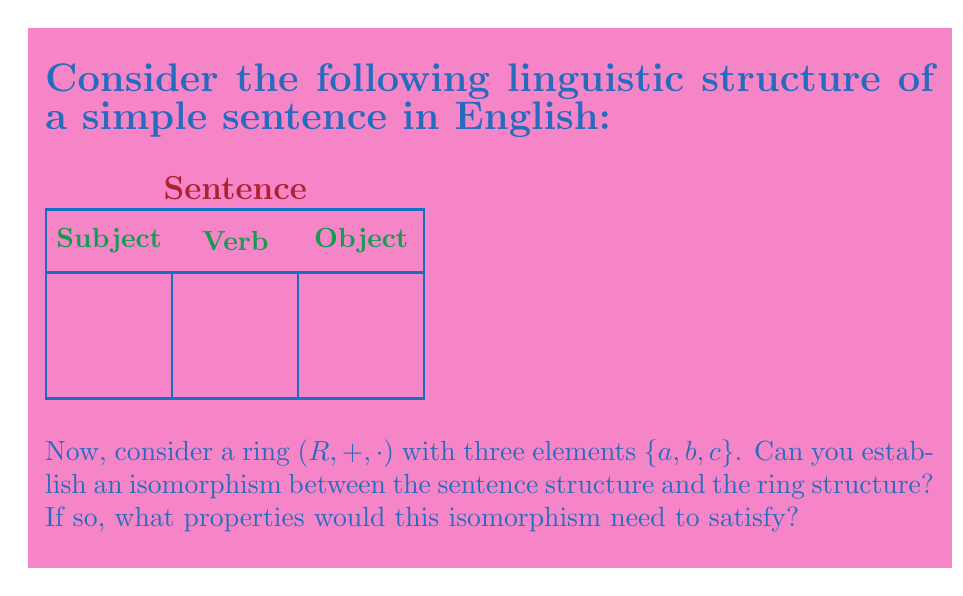Can you solve this math problem? To establish an isomorphism between the sentence structure and the ring structure, we need to consider the following steps:

1) First, we need to identify the elements and operations in both structures:

   Sentence structure: {Subject, Verb, Object}
   Ring structure: $\{a, b, c\}$ with operations $+$ and $\cdot$

2) An isomorphism $\phi$ between these structures would be a bijective function that preserves the structure. Let's define:

   $\phi(\text{Subject}) = a$
   $\phi(\text{Verb}) = b$
   $\phi(\text{Object}) = c$

3) For this to be an isomorphism, we need to define operations on the sentence structure that correspond to $+$ and $\cdot$ in the ring.

4) Let's consider the addition operation $+$ in the ring. In linguistic terms, this could correspond to coordination or concatenation of sentence elements. For example:

   Subject + Verb = Subject-Verb compound
   Verb + Object = Verb-Object compound

5) The multiplication operation $\cdot$ in the ring could correspond to the formation of a complete sentence. For example:

   Subject $\cdot$ Verb = Subject-Verb clause
   (Subject $\cdot$ Verb) $\cdot$ Object = Complete sentence

6) For $\phi$ to be an isomorphism, it must satisfy:

   $\phi(x + y) = \phi(x) + \phi(y)$
   $\phi(x \cdot y) = \phi(x) \cdot \phi(y)$

   where $x$ and $y$ are elements of the sentence structure.

7) Additionally, the ring properties must be reflected in the sentence structure:

   - Closure: Combining any two sentence elements should result in a valid linguistic construct.
   - Associativity: (Subject + Verb) + Object = Subject + (Verb + Object)
   - Commutativity of addition: Subject + Verb = Verb + Subject
   - Distributivity: Subject $\cdot$ (Verb + Object) = (Subject $\cdot$ Verb) + (Subject $\cdot$ Object)

8) The existence of identity elements and inverse elements in the ring should also have linguistic counterparts.

While this isomorphism is theoretical and simplistic, it demonstrates how abstract algebraic structures can be mapped onto linguistic concepts, potentially providing new insights into language structure and analysis.
Answer: Yes, an isomorphism can be established if linguistic operations analogous to ring operations are defined, preserving structure and satisfying ring properties. 